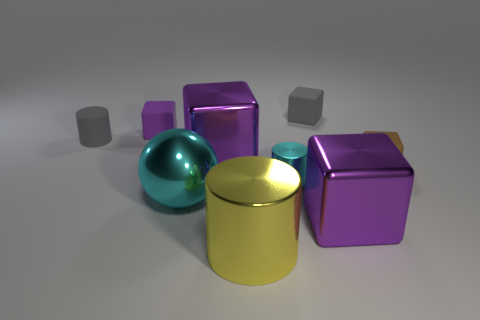Does the gray matte thing that is to the right of the yellow metallic thing have the same size as the metallic thing on the right side of the tiny cyan metallic object?
Offer a very short reply. No. Is the number of small gray objects on the left side of the large metallic ball greater than the number of purple shiny objects right of the large yellow metallic cylinder?
Offer a terse response. No. Are there any cylinders that have the same material as the cyan sphere?
Offer a very short reply. Yes. Is the color of the small metal cylinder the same as the big shiny sphere?
Ensure brevity in your answer.  Yes. What material is the small block that is on the left side of the brown rubber object and on the right side of the large shiny cylinder?
Your answer should be compact. Rubber. The metallic ball has what color?
Offer a very short reply. Cyan. What number of small brown objects are the same shape as the small purple matte thing?
Your answer should be compact. 1. Is the material of the large thing that is to the right of the small gray block the same as the small cyan object in front of the gray rubber cube?
Your answer should be compact. Yes. There is a purple block that is right of the cyan shiny cylinder on the left side of the tiny brown matte object; what size is it?
Provide a short and direct response. Large. Are there any other things that are the same size as the gray matte block?
Give a very brief answer. Yes. 